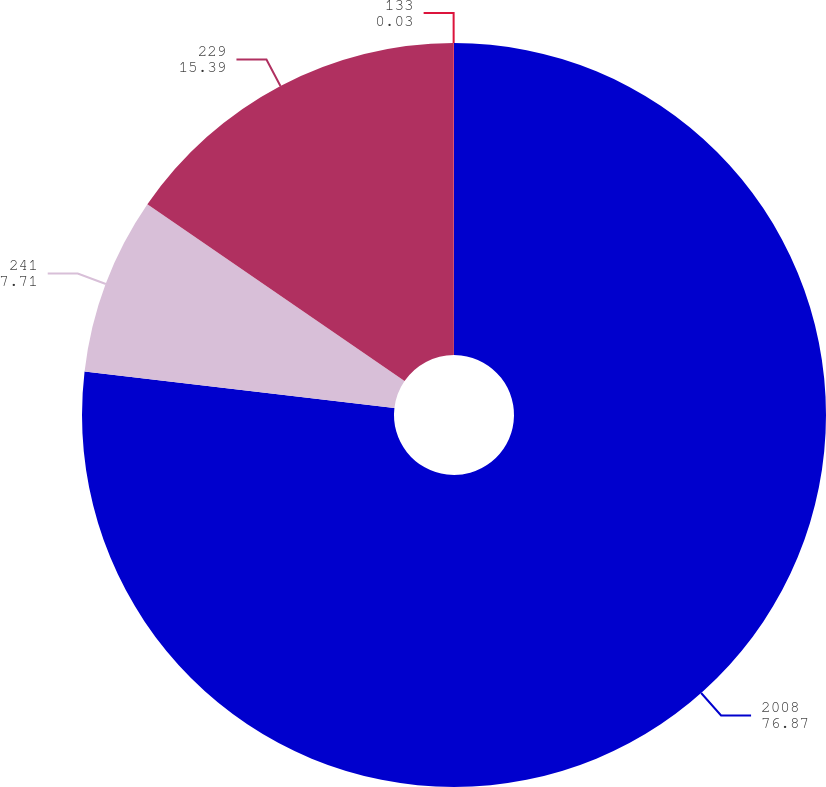Convert chart to OTSL. <chart><loc_0><loc_0><loc_500><loc_500><pie_chart><fcel>2008<fcel>241<fcel>229<fcel>133<nl><fcel>76.87%<fcel>7.71%<fcel>15.39%<fcel>0.03%<nl></chart> 